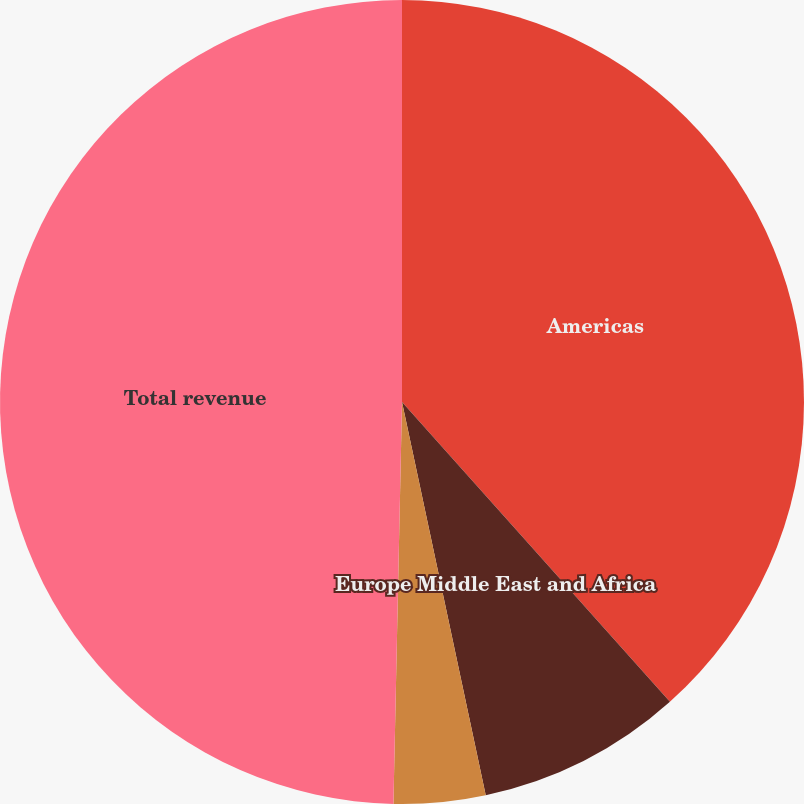<chart> <loc_0><loc_0><loc_500><loc_500><pie_chart><fcel>Americas<fcel>Europe Middle East and Africa<fcel>Asia-Pacific<fcel>Total revenue<nl><fcel>38.39%<fcel>8.27%<fcel>3.68%<fcel>49.66%<nl></chart> 